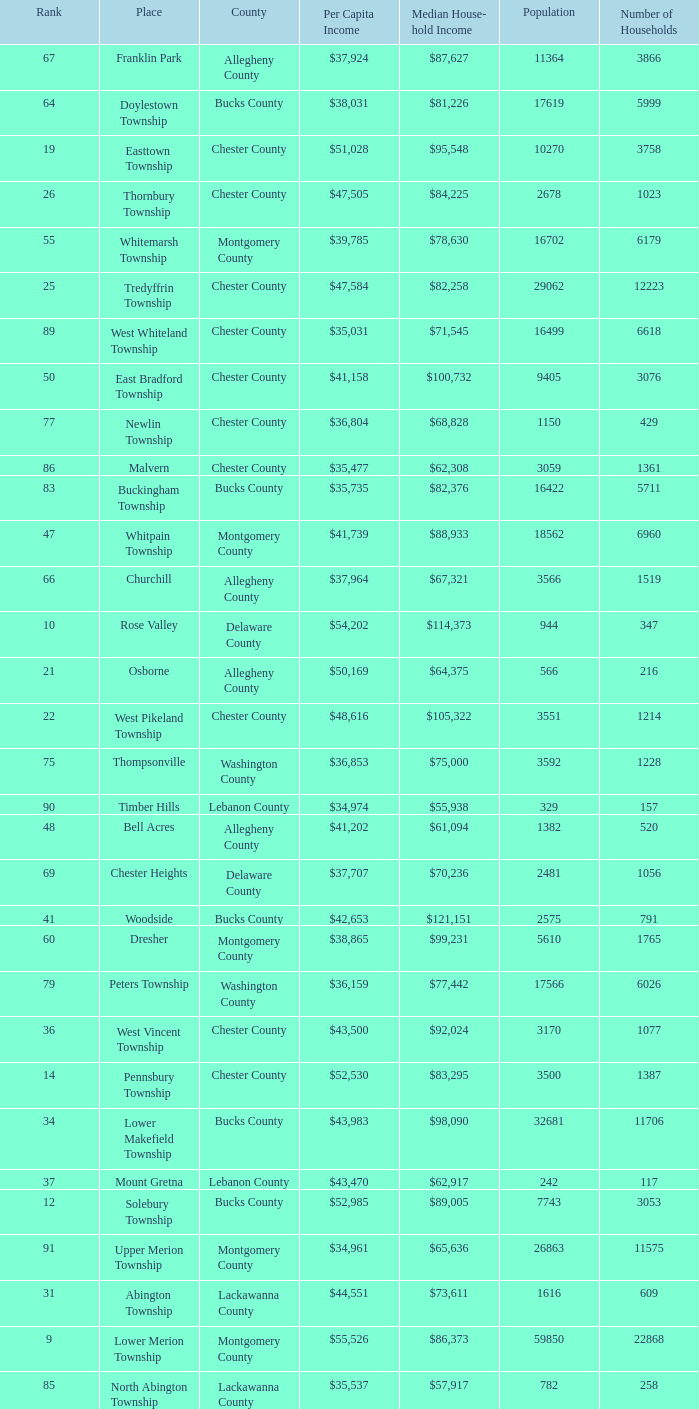What is the per capita income for Fayette County? $42,131. Could you help me parse every detail presented in this table? {'header': ['Rank', 'Place', 'County', 'Per Capita Income', 'Median House- hold Income', 'Population', 'Number of Households'], 'rows': [['67', 'Franklin Park', 'Allegheny County', '$37,924', '$87,627', '11364', '3866'], ['64', 'Doylestown Township', 'Bucks County', '$38,031', '$81,226', '17619', '5999'], ['19', 'Easttown Township', 'Chester County', '$51,028', '$95,548', '10270', '3758'], ['26', 'Thornbury Township', 'Chester County', '$47,505', '$84,225', '2678', '1023'], ['55', 'Whitemarsh Township', 'Montgomery County', '$39,785', '$78,630', '16702', '6179'], ['25', 'Tredyffrin Township', 'Chester County', '$47,584', '$82,258', '29062', '12223'], ['89', 'West Whiteland Township', 'Chester County', '$35,031', '$71,545', '16499', '6618'], ['50', 'East Bradford Township', 'Chester County', '$41,158', '$100,732', '9405', '3076'], ['77', 'Newlin Township', 'Chester County', '$36,804', '$68,828', '1150', '429'], ['86', 'Malvern', 'Chester County', '$35,477', '$62,308', '3059', '1361'], ['83', 'Buckingham Township', 'Bucks County', '$35,735', '$82,376', '16422', '5711'], ['47', 'Whitpain Township', 'Montgomery County', '$41,739', '$88,933', '18562', '6960'], ['66', 'Churchill', 'Allegheny County', '$37,964', '$67,321', '3566', '1519'], ['10', 'Rose Valley', 'Delaware County', '$54,202', '$114,373', '944', '347'], ['21', 'Osborne', 'Allegheny County', '$50,169', '$64,375', '566', '216'], ['22', 'West Pikeland Township', 'Chester County', '$48,616', '$105,322', '3551', '1214'], ['75', 'Thompsonville', 'Washington County', '$36,853', '$75,000', '3592', '1228'], ['90', 'Timber Hills', 'Lebanon County', '$34,974', '$55,938', '329', '157'], ['48', 'Bell Acres', 'Allegheny County', '$41,202', '$61,094', '1382', '520'], ['69', 'Chester Heights', 'Delaware County', '$37,707', '$70,236', '2481', '1056'], ['41', 'Woodside', 'Bucks County', '$42,653', '$121,151', '2575', '791'], ['60', 'Dresher', 'Montgomery County', '$38,865', '$99,231', '5610', '1765'], ['79', 'Peters Township', 'Washington County', '$36,159', '$77,442', '17566', '6026'], ['36', 'West Vincent Township', 'Chester County', '$43,500', '$92,024', '3170', '1077'], ['14', 'Pennsbury Township', 'Chester County', '$52,530', '$83,295', '3500', '1387'], ['34', 'Lower Makefield Township', 'Bucks County', '$43,983', '$98,090', '32681', '11706'], ['37', 'Mount Gretna', 'Lebanon County', '$43,470', '$62,917', '242', '117'], ['12', 'Solebury Township', 'Bucks County', '$52,985', '$89,005', '7743', '3053'], ['91', 'Upper Merion Township', 'Montgomery County', '$34,961', '$65,636', '26863', '11575'], ['31', 'Abington Township', 'Lackawanna County', '$44,551', '$73,611', '1616', '609'], ['9', 'Lower Merion Township', 'Montgomery County', '$55,526', '$86,373', '59850', '22868'], ['85', 'North Abington Township', 'Lackawanna County', '$35,537', '$57,917', '782', '258'], ['62', 'Exton', 'Chester County', '$38,589', '$68,240', '4267', '2053'], ['96', 'Wyomissing Hills', 'Berks County', '$34,024', '$61,364', '2568', '986'], ['78', 'Wyndmoor', 'Montgomery County', '$36,205', '$72,219', '5601', '2144'], ['5', 'Edgeworth', 'Allegheny County', '$69,350', '$99,144', '1730', '644'], ['1', 'Norwin', 'Westmoreland County', '$124,279', '$94,239', '18', '7'], ['57', 'Newtown Township', 'Delaware County', '$39,364', '$65,924', '11700', '4549'], ['54', 'Radnor Township', 'Delaware County', '$39,813', '$74,272', '30878', '10347'], ['76', 'Flying Hills', 'Berks County', '$36,822', '$59,596', '1191', '592'], ['95', 'Worcester Township', 'Montgomery County', '$34,264', '$77,200', '7789', '2896'], ['44', 'Seven Springs', 'Fayette County', '$42,131', '$48,750', '127', '63'], ['38', 'Schuylkill Township', 'Chester County', '$43,379', '$86,092', '6960', '2536'], ['80', 'Ardmore', 'Montgomery County', '$36,111', '$60,966', '12616', '5529'], ['58', 'Adams Township', 'Butler County', '$39,204', '$65,357', '6774', '2382'], ['52', 'Lafayette Hill', 'Montgomery County', '$40,363', '$84,835', '10226', '3783'], ['42', 'Wrightstown Township', 'Bucks County', '$42,623', '$82,875', '2839', '971'], ['61', 'Sewickley Hills', 'Allegheny County', '$38,681', '$79,466', '652', '225'], ['40', 'Marshall Township', 'Allegheny County', '$42,856', '$102,351', '5996', '1944'], ['71', 'Wyomissing', 'Berks County', '$37,313', '$54,681', '8587', '3359'], ['84', 'Devon-Berwyn', 'Chester County', '$35,551', '$74,886', '5067', '1978'], ['17', 'Birmingham Township', 'Chester County', '$51,756', '$130,096', '4221', '1391'], ['3', 'Fox Chapel', 'Allegheny County', '$80,610', '$141,298', '5436', '1875'], ['88', 'Narberth', 'Montgomery County', '$35,165', '$60,408', '4233', '1904'], ['49', 'Penn Wynne', 'Montgomery County', '$41,199', '$78,398', '5382', '2072'], ['33', 'Bala-Cynwyd', 'Montgomery County', '$44,027', '$78,932', '9336', '3726'], ['20', 'Villanova', 'Montgomery County', '$50,204', '$159,538', '9060', '1902'], ['29', 'New Hope', 'Bucks County', '$45,309', '$60,833', '2252', '1160'], ['28', 'Kennett Township', 'Chester County', '$46,669', '$85,104', '6451', '2457'], ['93', 'Newtown Township', 'Bucks County', '$34,335', '$80,532', '18206', '6761'], ['63', 'East Marlborough Township', 'Chester County', '$38,090', '$95,812', '6317', '2131'], ['4', 'Sewickley Heights', 'Allegheny County', '$74,346', '$115,672', '981', '336'], ['87', 'Pine Township', 'Allegheny County', '$35,202', '$85,817', '7683', '2411'], ['24', 'Spring House', 'Montgomery County', '$47,661', '$89,000', '3290', '1347'], ['39', 'Fort Washington', 'Montgomery County', '$43,090', '$103,469', '3680', '1161'], ['94', 'Tinicum Township', 'Bucks County', '$34,321', '$60,843', '4206', '1674'], ['46', 'Lower Gwynedd Township', 'Montgomery County', '$41,868', '$74,351', '10422', '4177'], ['16', 'Chesterbrook', 'Chester County', '$51,859', '$80,792', '4625', '2356'], ['23', 'Spring Ridge', 'Berks County', '$47,822', '$83,345', '786', '370'], ['6', 'Thornburg', 'Allegheny County', '$57,674', '$83,264', '468', '177'], ['68', 'East Goshen Township', 'Chester County', '$37,775', '$64,777', '16824', '7165'], ['53', 'Lower Moreland Township', 'Montgomery County', '$40,129', '$82,597', '11281', '4112'], ['82', 'London Britain Township', 'Chester County', '$35,761', '$93,521', '2797', '957'], ['8', 'Upper Makefield Township', 'Bucks County', '$56,288', '$102,759', '7180', '2512'], ['81', 'Clarks Green', 'Lackawanna County', '$35,975', '$61,250', '1630', '616'], ['7', 'Rosslyn Farms', 'Allegheny County', '$56,612', '$87,500', '464', '184'], ['99', 'Uwchlan Township', 'Chester County', '$33,785', '$81,985', '16576', '5921'], ['11', 'Haysville', 'Allegheny County', '$53,151', '$33,750', '78', '36'], ['97', 'Woodbourne', 'Bucks County', '$33,821', '$107,913', '3512', '1008'], ['56', 'Upper Providence Township', 'Delaware County', '$39,532', '$71,166', '10509', '4075'], ['15', 'Pocopson Township', 'Chester County', '$51,883', '$98,215', '3350', '859'], ['92', 'Homewood', 'Beaver County', '$34,486', '$33,333', '147', '59'], ['73', 'Aleppo Township', 'Allegheny County', '$37,187', '$59,167', '1039', '483'], ['72', 'Heath Township', 'Jefferson County', '$37,309', '$42,500', '160', '77'], ['51', 'Swarthmore', 'Delaware County', '$40,482', '$82,653', '6170', '1993'], ['65', 'Upper Dublin Township', 'Montgomery County', '$37,994', '$80,093', '25878', '9174'], ['35', 'Blue Bell', 'Montgomery County', '$43,813', '$94,160', '6395', '2434'], ['30', 'Willistown', 'Chester County', '$45,010', '$77,555', '10011', '3806'], ['18', 'Bradford Woods', 'Allegheny County', '$51,462', '$92,820', '1149', '464'], ['43', 'Upper St.Clair Township', 'Allegheny County', '$42,413', '$87,581', '20053', '6966'], ['27', 'Edgmont Township', 'Delaware County', '$46,848', '$88,303', '3918', '1447'], ['13', 'Chadds Ford Township', 'Delaware County', '$52,974', '$84,100', '3170', '1314'], ['74', 'Westtown Township', 'Chester County', '$36,894', '$85,049', '10352', '3705'], ['98', 'Concord Township', 'Delaware County', '$33,800', '$85,503', '9933', '3384'], ['70', 'McMurray', 'Washington County', '$37,364', '$81,736', '4726', '1582'], ['2', 'Gladwyne', 'Montgomery County', '$90,940', '$159,905', '4050', '1476'], ['59', 'Edgewood', 'Allegheny County', '$39,188', '$52,153', '3311', '1639'], ['32', 'Ben Avon Heights', 'Allegheny County', '$44,191', '$105,006', '392', '138'], ['45', 'Charlestown Township', 'Chester County', '$41,878', '$89,813', '4051', '1340']]} 